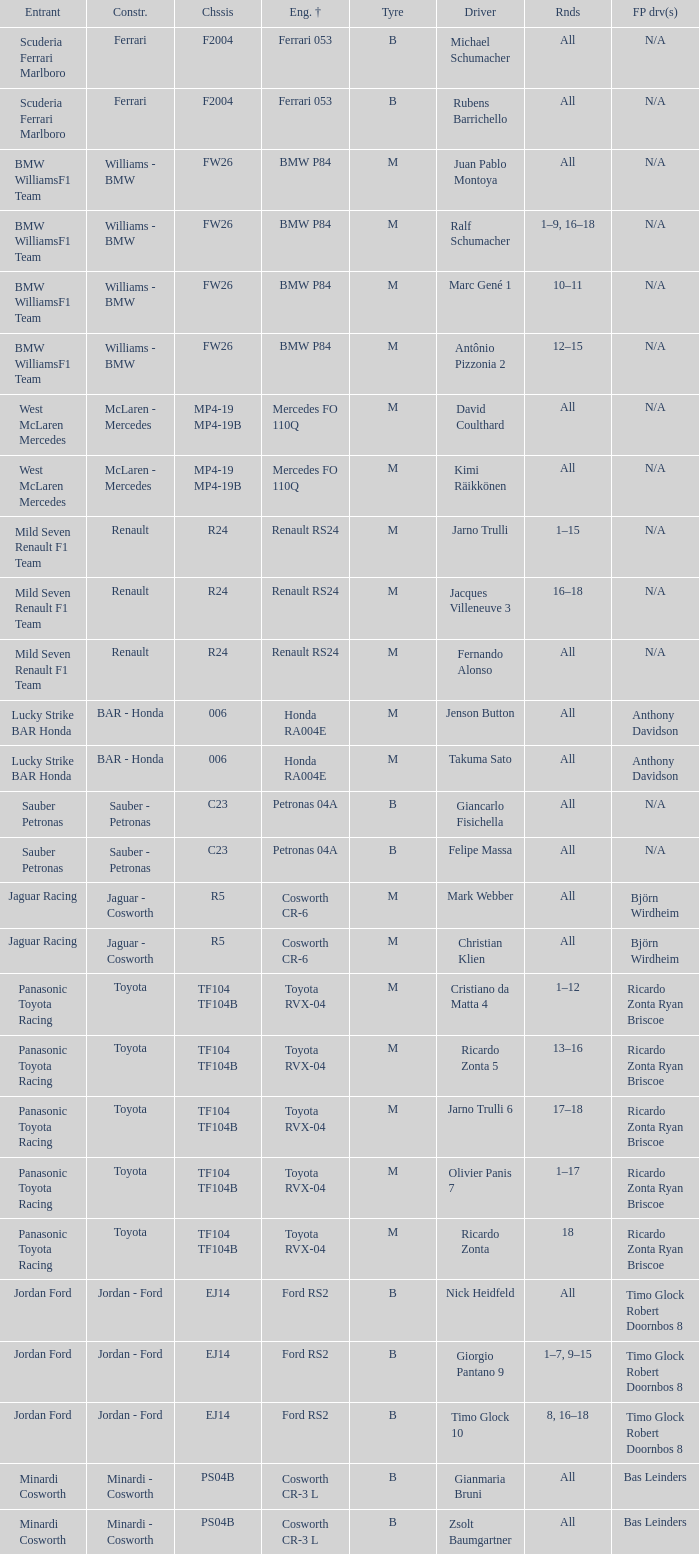What kind of chassis does Ricardo Zonta have? TF104 TF104B. 